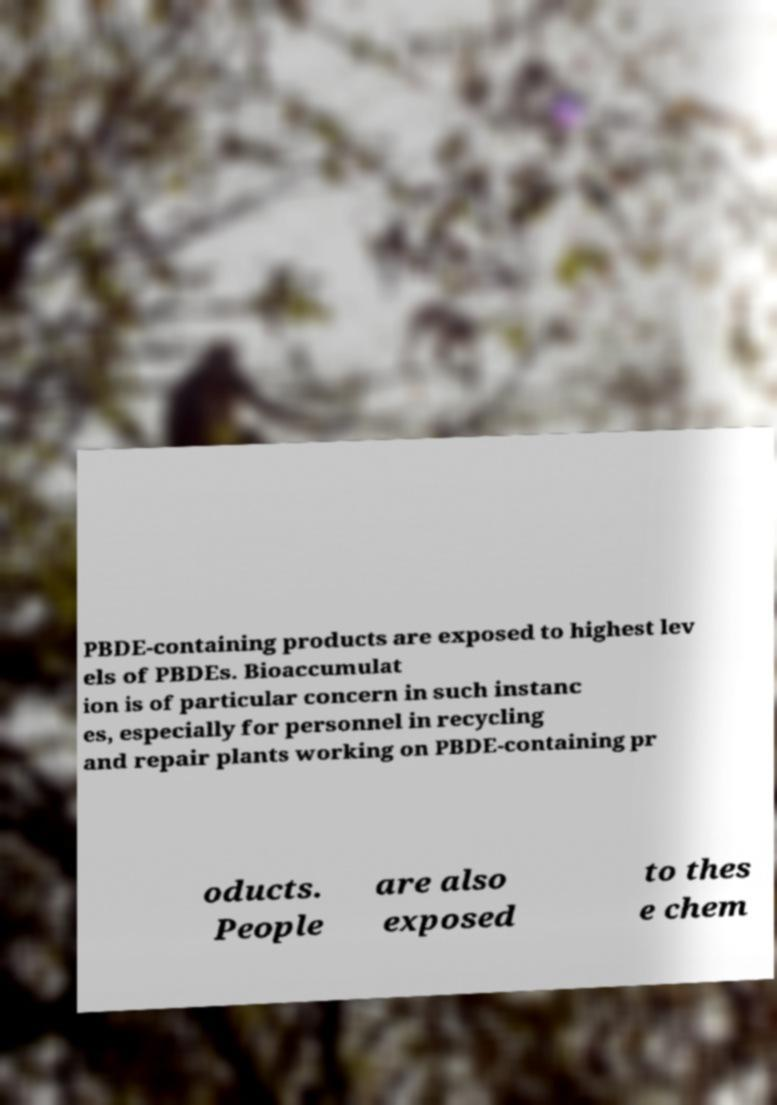Can you accurately transcribe the text from the provided image for me? PBDE-containing products are exposed to highest lev els of PBDEs. Bioaccumulat ion is of particular concern in such instanc es, especially for personnel in recycling and repair plants working on PBDE-containing pr oducts. People are also exposed to thes e chem 